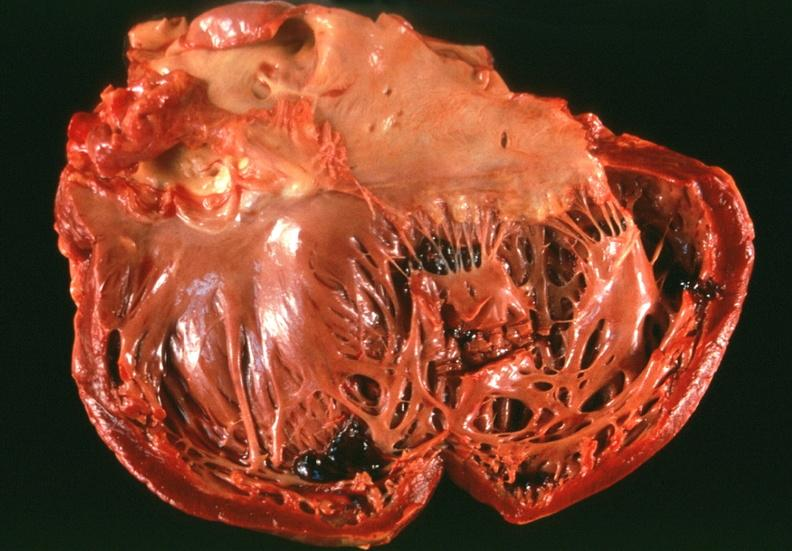what does this image show?
Answer the question using a single word or phrase. Congestive heart failure 